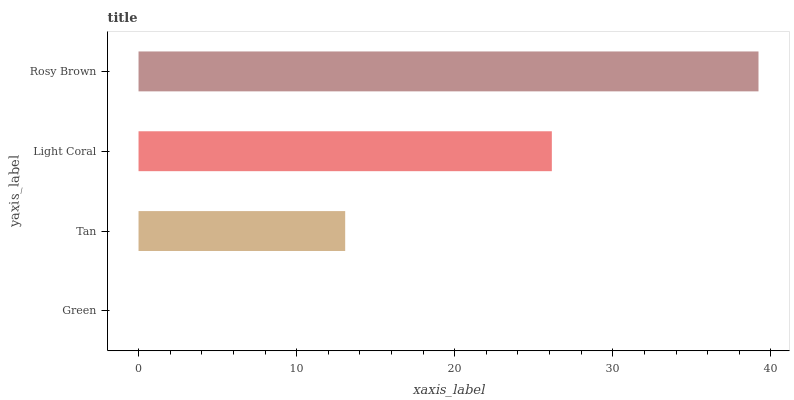Is Green the minimum?
Answer yes or no. Yes. Is Rosy Brown the maximum?
Answer yes or no. Yes. Is Tan the minimum?
Answer yes or no. No. Is Tan the maximum?
Answer yes or no. No. Is Tan greater than Green?
Answer yes or no. Yes. Is Green less than Tan?
Answer yes or no. Yes. Is Green greater than Tan?
Answer yes or no. No. Is Tan less than Green?
Answer yes or no. No. Is Light Coral the high median?
Answer yes or no. Yes. Is Tan the low median?
Answer yes or no. Yes. Is Rosy Brown the high median?
Answer yes or no. No. Is Rosy Brown the low median?
Answer yes or no. No. 